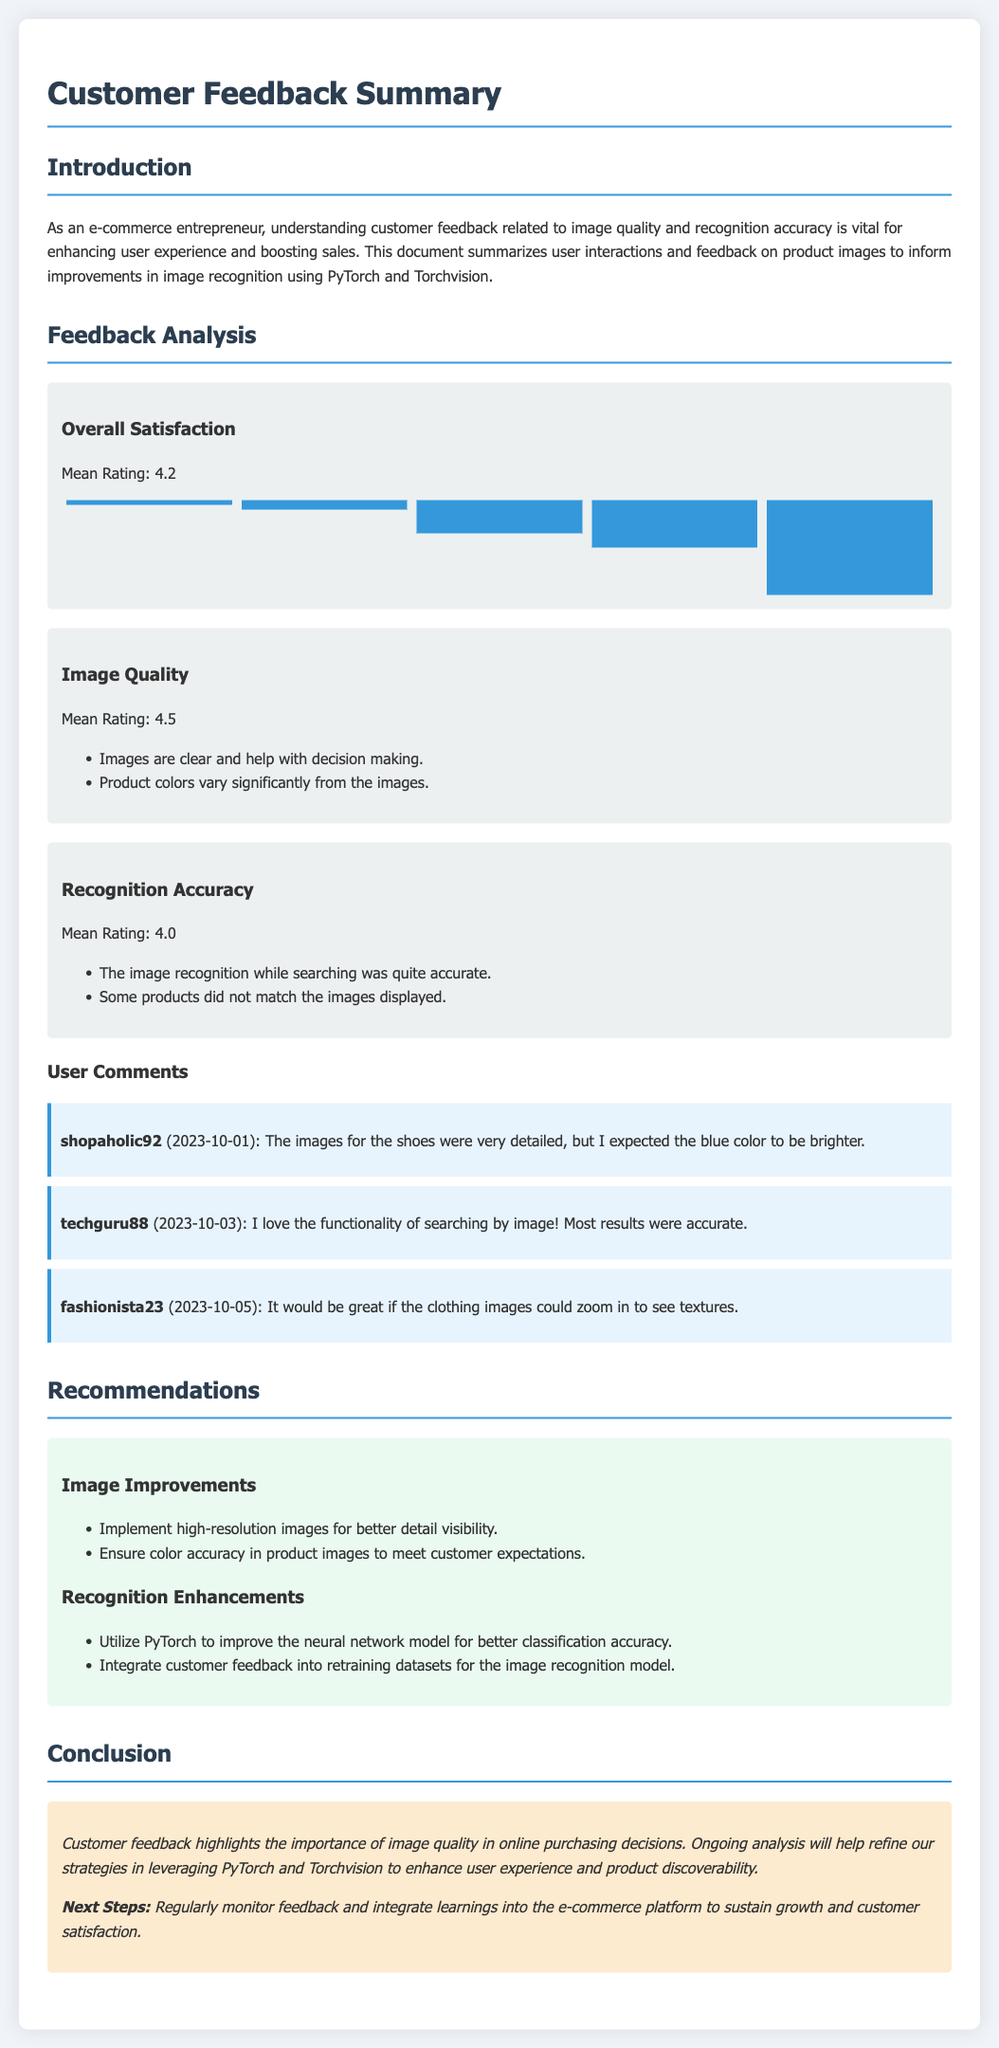What is the mean rating for overall satisfaction? The mean rating for overall satisfaction is provided in the feedback analysis section.
Answer: 4.2 What is the mean rating for image quality? The mean rating for image quality can be found in the feedback analysis section.
Answer: 4.5 Which user commented about the shoe images? The document lists specific user comments, one of which mentions shoe images.
Answer: shopaholic92 What recommendation is made for image improvements? The recommendations section provides suggestions for enhancing image quality.
Answer: Implement high-resolution images for better detail visibility What is mentioned about color accuracy in product images? The document mentions customer feedback about color accuracy in the image quality section.
Answer: Ensure color accuracy in product images to meet customer expectations What is the mean rating for recognition accuracy? The mean rating for recognition accuracy is included in the feedback analysis section.
Answer: 4.0 Who commented on the functionality of searching by image? The comments section lists users and their feedback, including one about image search functionality.
Answer: techguru88 What specific enhancement is recommended for recognition accuracy? The recommendations section suggests improvements for image recognition.
Answer: Utilize PyTorch to improve the neural network model for better classification accuracy 